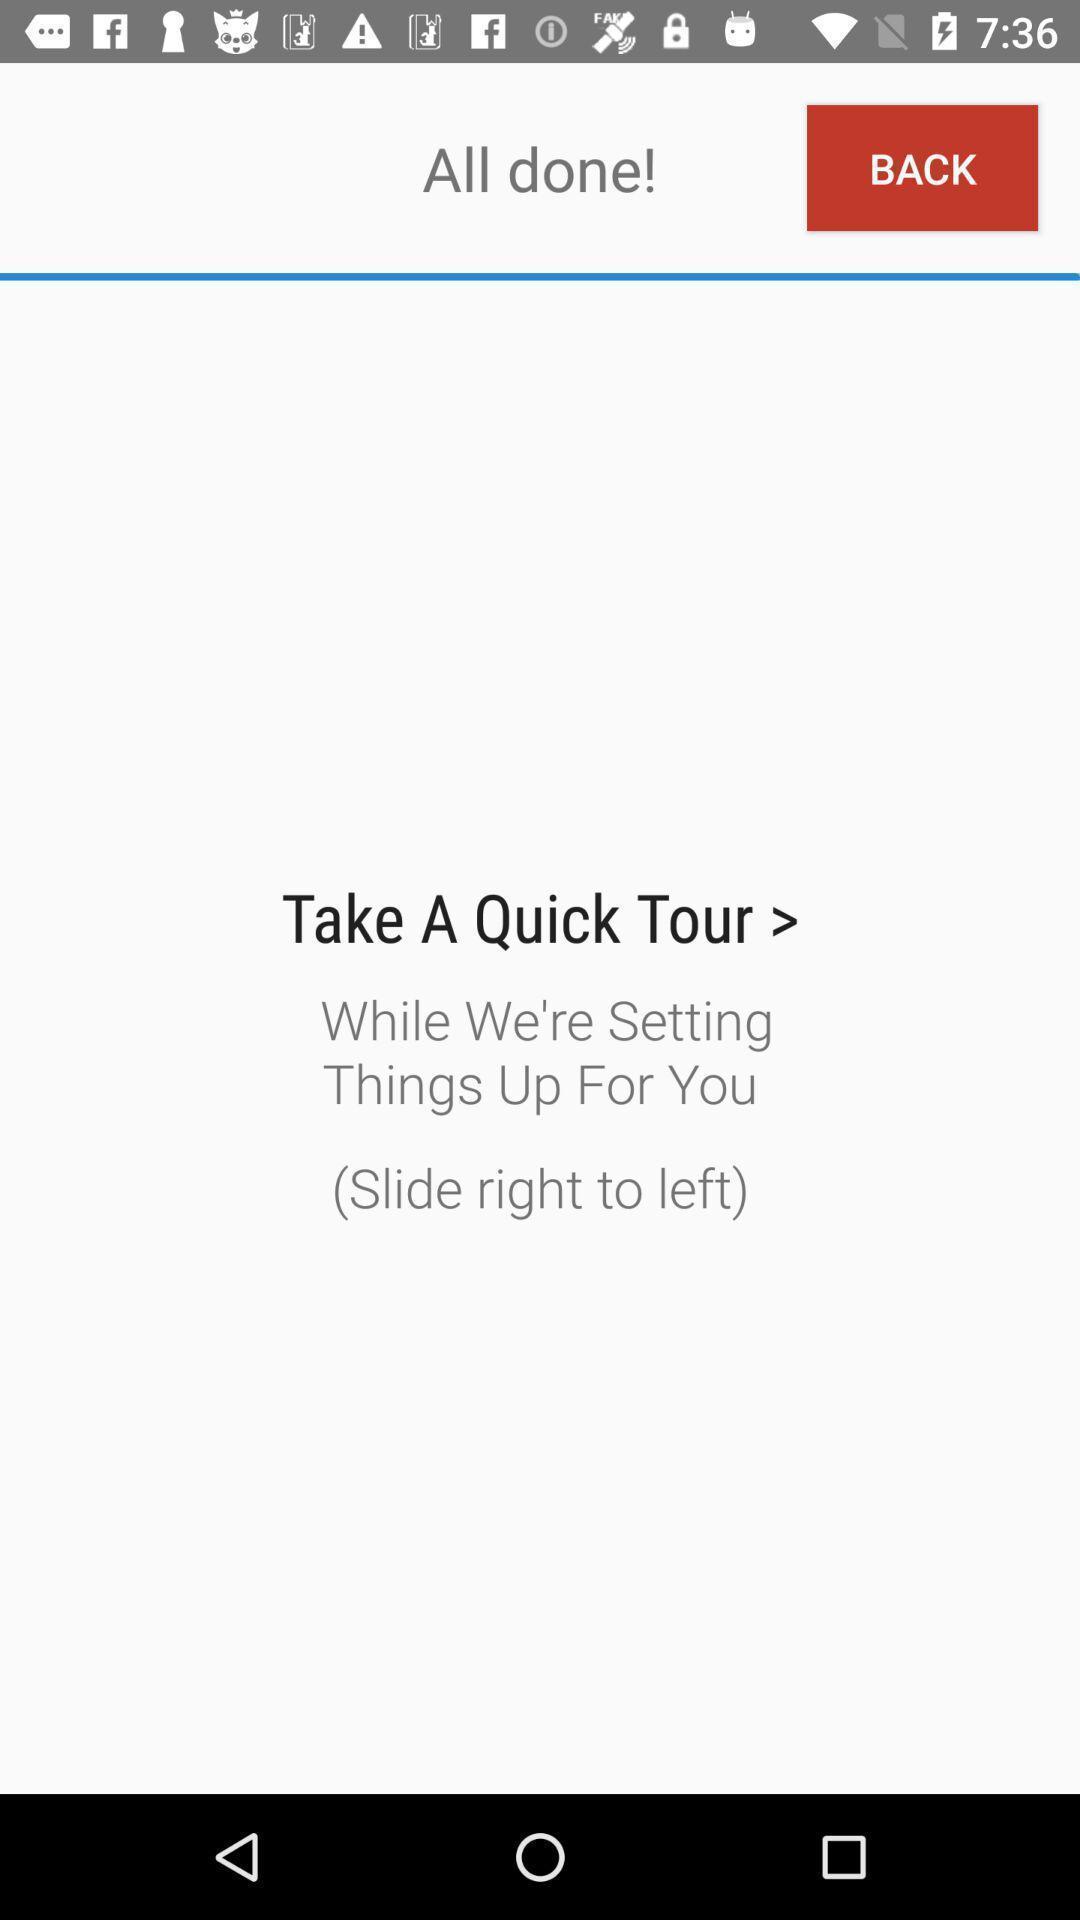Describe the content in this image. Screen shows few settings on a device. 